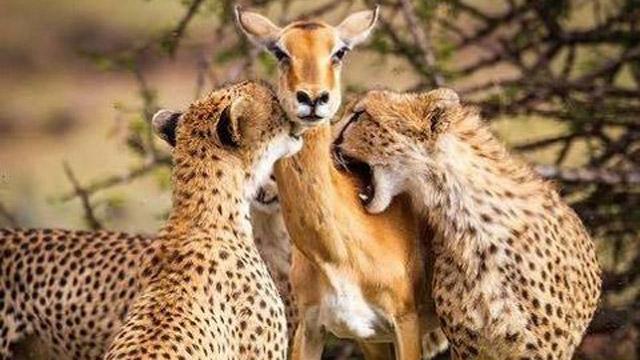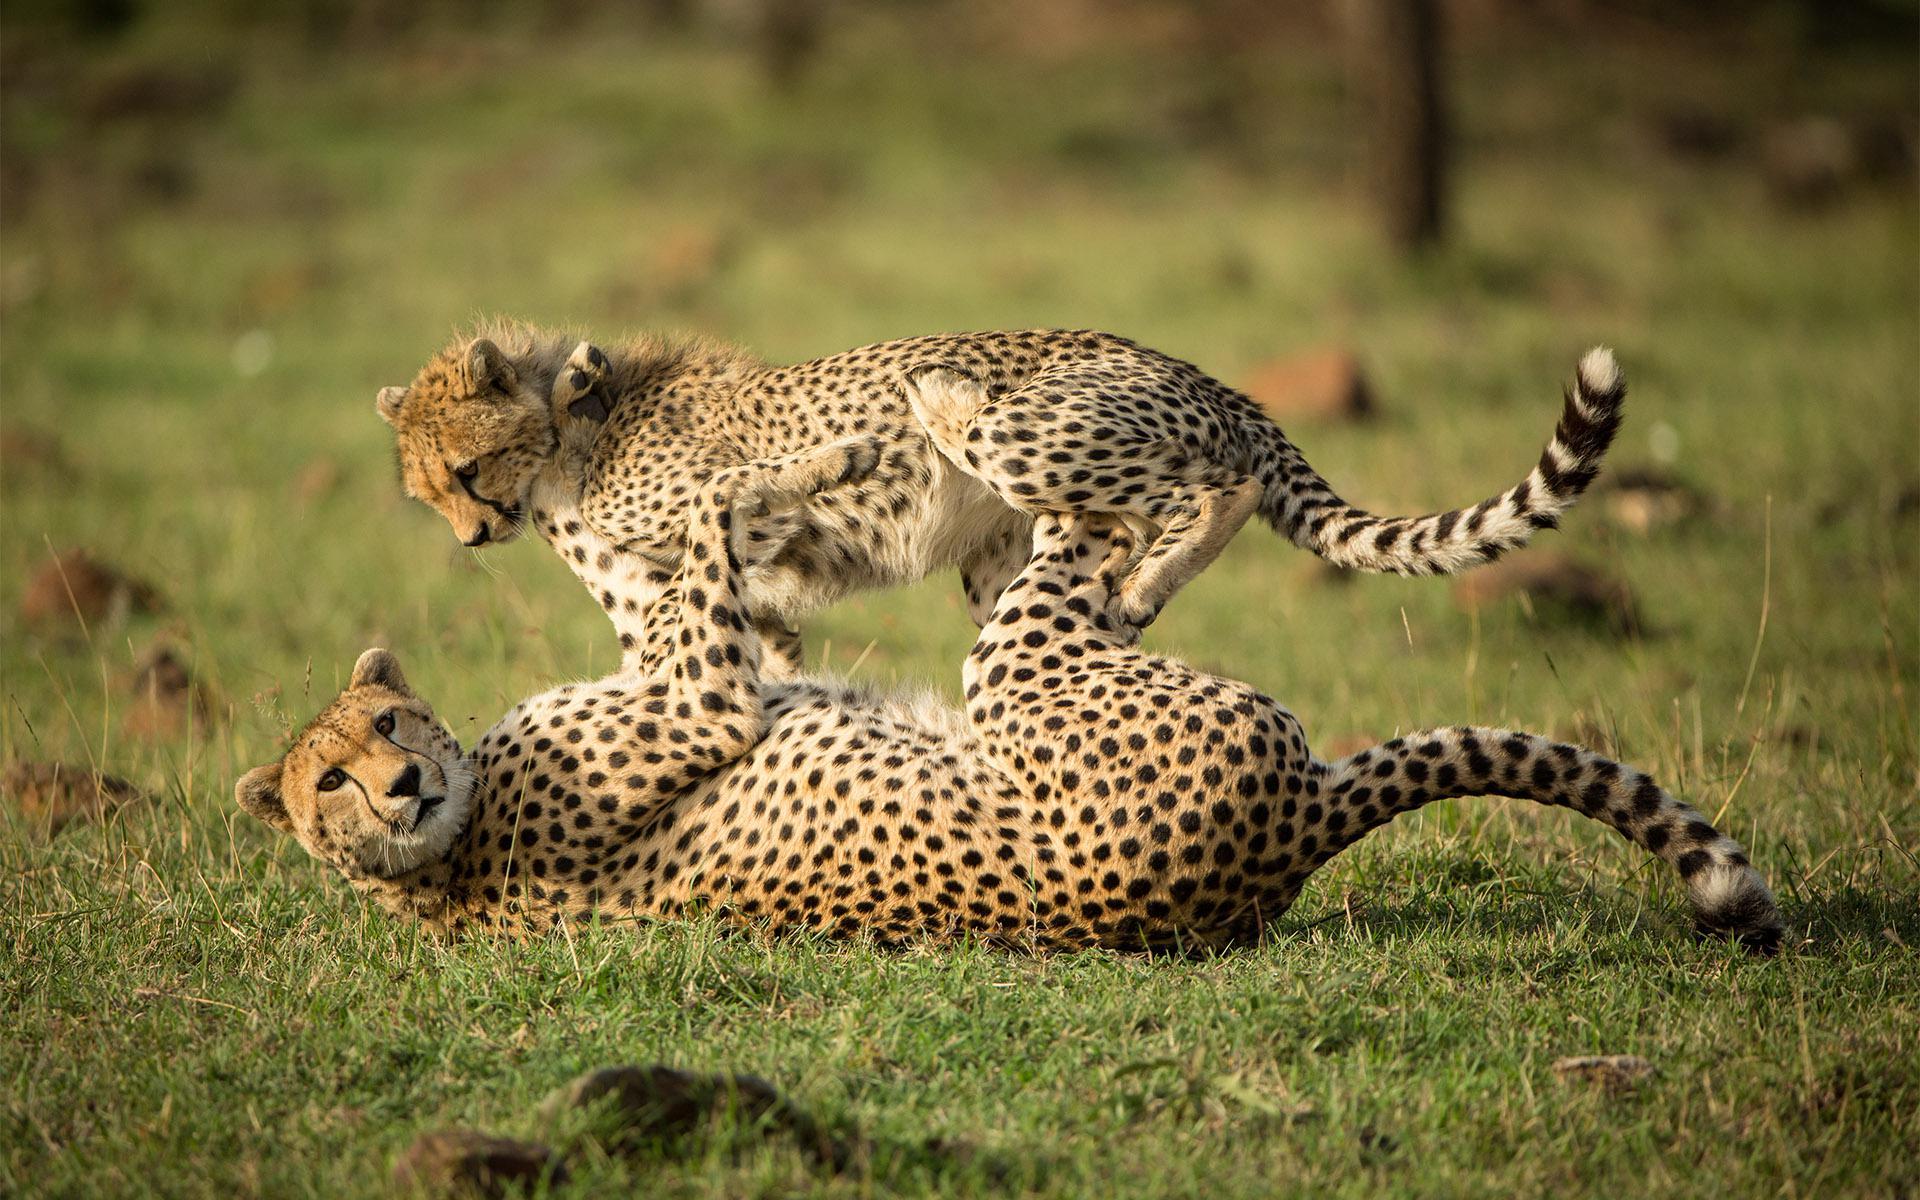The first image is the image on the left, the second image is the image on the right. For the images shown, is this caption "A cheetah's paw is on a deer's face in at last one of the images." true? Answer yes or no. No. 